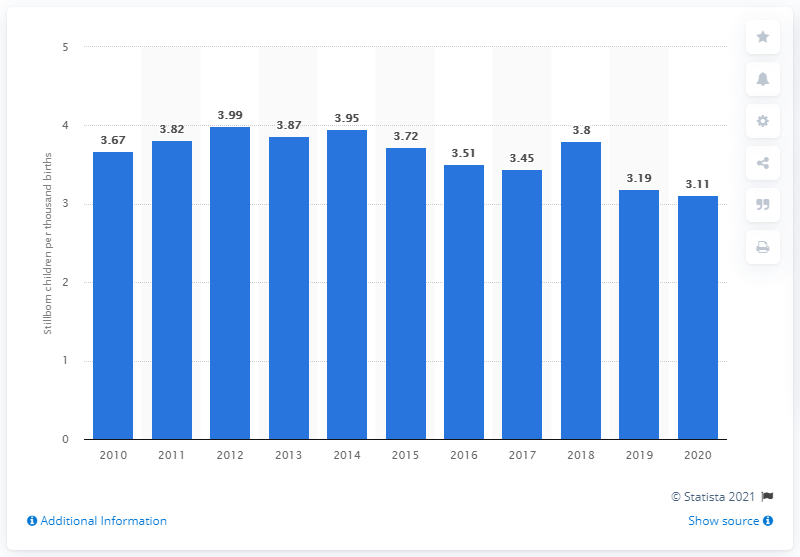Mention a couple of crucial points in this snapshot. There were approximately 3.11 stillborn children per thousand births in Sweden in 2020. 